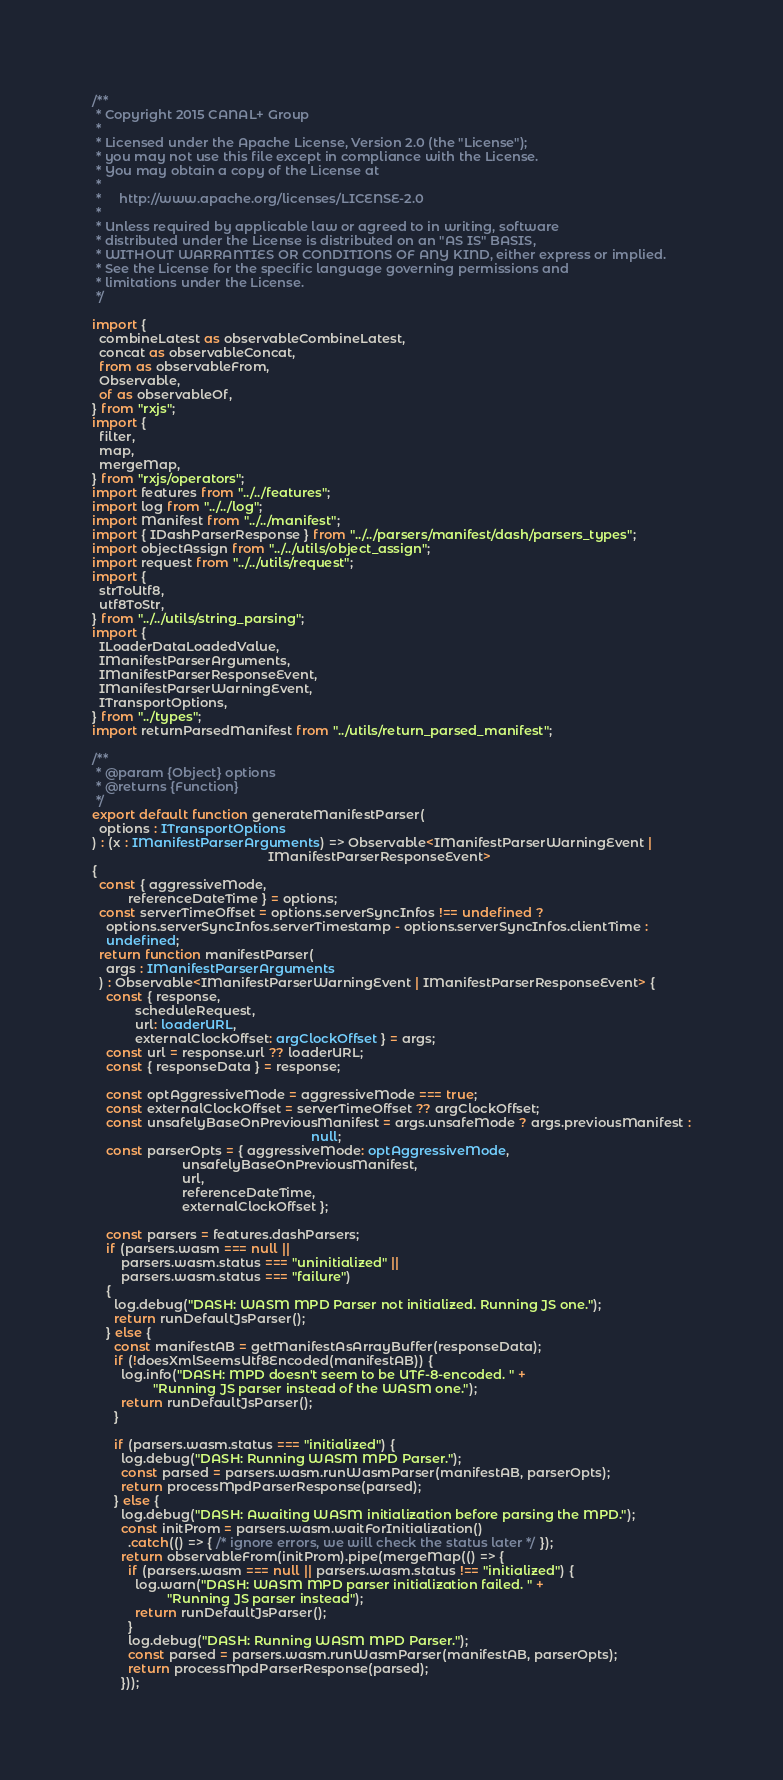Convert code to text. <code><loc_0><loc_0><loc_500><loc_500><_TypeScript_>/**
 * Copyright 2015 CANAL+ Group
 *
 * Licensed under the Apache License, Version 2.0 (the "License");
 * you may not use this file except in compliance with the License.
 * You may obtain a copy of the License at
 *
 *     http://www.apache.org/licenses/LICENSE-2.0
 *
 * Unless required by applicable law or agreed to in writing, software
 * distributed under the License is distributed on an "AS IS" BASIS,
 * WITHOUT WARRANTIES OR CONDITIONS OF ANY KIND, either express or implied.
 * See the License for the specific language governing permissions and
 * limitations under the License.
 */

import {
  combineLatest as observableCombineLatest,
  concat as observableConcat,
  from as observableFrom,
  Observable,
  of as observableOf,
} from "rxjs";
import {
  filter,
  map,
  mergeMap,
} from "rxjs/operators";
import features from "../../features";
import log from "../../log";
import Manifest from "../../manifest";
import { IDashParserResponse } from "../../parsers/manifest/dash/parsers_types";
import objectAssign from "../../utils/object_assign";
import request from "../../utils/request";
import {
  strToUtf8,
  utf8ToStr,
} from "../../utils/string_parsing";
import {
  ILoaderDataLoadedValue,
  IManifestParserArguments,
  IManifestParserResponseEvent,
  IManifestParserWarningEvent,
  ITransportOptions,
} from "../types";
import returnParsedManifest from "../utils/return_parsed_manifest";

/**
 * @param {Object} options
 * @returns {Function}
 */
export default function generateManifestParser(
  options : ITransportOptions
) : (x : IManifestParserArguments) => Observable<IManifestParserWarningEvent |
                                                 IManifestParserResponseEvent>
{
  const { aggressiveMode,
          referenceDateTime } = options;
  const serverTimeOffset = options.serverSyncInfos !== undefined ?
    options.serverSyncInfos.serverTimestamp - options.serverSyncInfos.clientTime :
    undefined;
  return function manifestParser(
    args : IManifestParserArguments
  ) : Observable<IManifestParserWarningEvent | IManifestParserResponseEvent> {
    const { response,
            scheduleRequest,
            url: loaderURL,
            externalClockOffset: argClockOffset } = args;
    const url = response.url ?? loaderURL;
    const { responseData } = response;

    const optAggressiveMode = aggressiveMode === true;
    const externalClockOffset = serverTimeOffset ?? argClockOffset;
    const unsafelyBaseOnPreviousManifest = args.unsafeMode ? args.previousManifest :
                                                             null;
    const parserOpts = { aggressiveMode: optAggressiveMode,
                         unsafelyBaseOnPreviousManifest,
                         url,
                         referenceDateTime,
                         externalClockOffset };

    const parsers = features.dashParsers;
    if (parsers.wasm === null ||
        parsers.wasm.status === "uninitialized" ||
        parsers.wasm.status === "failure")
    {
      log.debug("DASH: WASM MPD Parser not initialized. Running JS one.");
      return runDefaultJsParser();
    } else {
      const manifestAB = getManifestAsArrayBuffer(responseData);
      if (!doesXmlSeemsUtf8Encoded(manifestAB)) {
        log.info("DASH: MPD doesn't seem to be UTF-8-encoded. " +
                 "Running JS parser instead of the WASM one.");
        return runDefaultJsParser();
      }

      if (parsers.wasm.status === "initialized") {
        log.debug("DASH: Running WASM MPD Parser.");
        const parsed = parsers.wasm.runWasmParser(manifestAB, parserOpts);
        return processMpdParserResponse(parsed);
      } else {
        log.debug("DASH: Awaiting WASM initialization before parsing the MPD.");
        const initProm = parsers.wasm.waitForInitialization()
          .catch(() => { /* ignore errors, we will check the status later */ });
        return observableFrom(initProm).pipe(mergeMap(() => {
          if (parsers.wasm === null || parsers.wasm.status !== "initialized") {
            log.warn("DASH: WASM MPD parser initialization failed. " +
                     "Running JS parser instead");
            return runDefaultJsParser();
          }
          log.debug("DASH: Running WASM MPD Parser.");
          const parsed = parsers.wasm.runWasmParser(manifestAB, parserOpts);
          return processMpdParserResponse(parsed);
        }));</code> 